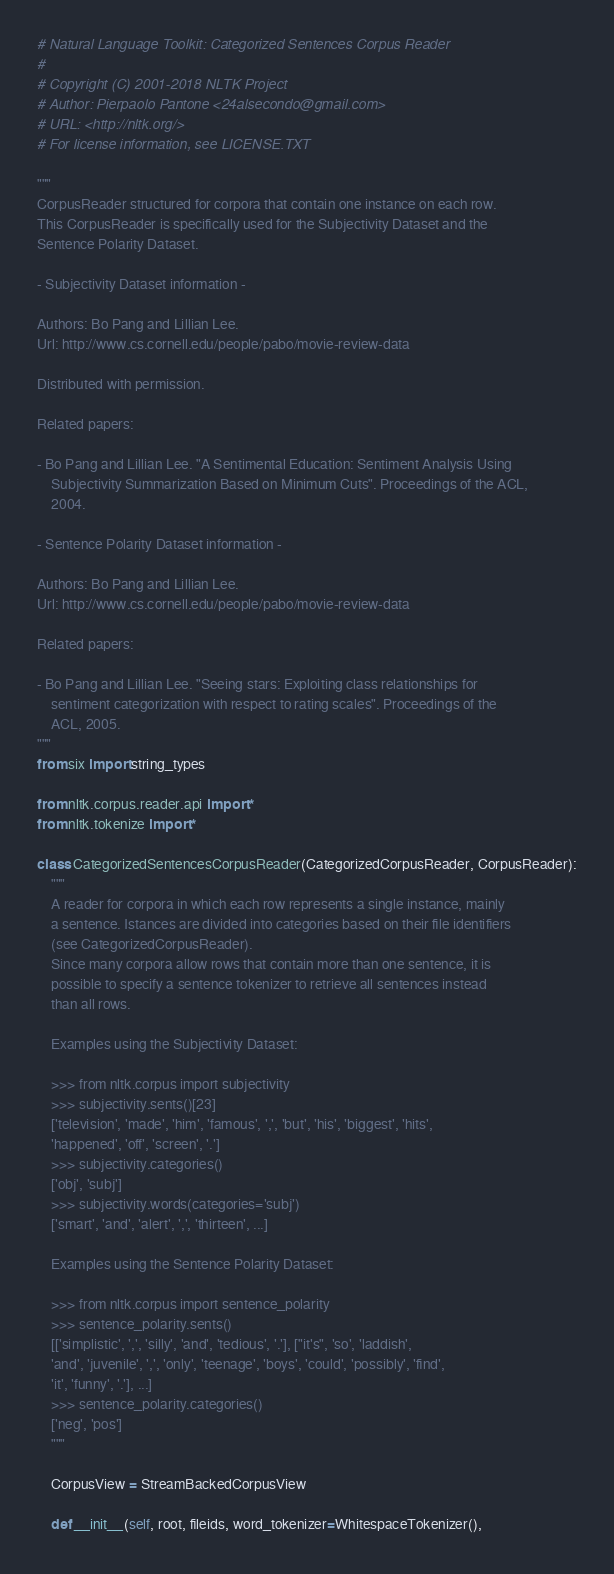<code> <loc_0><loc_0><loc_500><loc_500><_Python_># Natural Language Toolkit: Categorized Sentences Corpus Reader
#
# Copyright (C) 2001-2018 NLTK Project
# Author: Pierpaolo Pantone <24alsecondo@gmail.com>
# URL: <http://nltk.org/>
# For license information, see LICENSE.TXT

"""
CorpusReader structured for corpora that contain one instance on each row.
This CorpusReader is specifically used for the Subjectivity Dataset and the
Sentence Polarity Dataset.

- Subjectivity Dataset information -

Authors: Bo Pang and Lillian Lee.
Url: http://www.cs.cornell.edu/people/pabo/movie-review-data

Distributed with permission.

Related papers:

- Bo Pang and Lillian Lee. "A Sentimental Education: Sentiment Analysis Using
    Subjectivity Summarization Based on Minimum Cuts". Proceedings of the ACL,
    2004.

- Sentence Polarity Dataset information -

Authors: Bo Pang and Lillian Lee.
Url: http://www.cs.cornell.edu/people/pabo/movie-review-data

Related papers:

- Bo Pang and Lillian Lee. "Seeing stars: Exploiting class relationships for
    sentiment categorization with respect to rating scales". Proceedings of the
    ACL, 2005.
"""
from six import string_types

from nltk.corpus.reader.api import *
from nltk.tokenize import *

class CategorizedSentencesCorpusReader(CategorizedCorpusReader, CorpusReader):
    """
    A reader for corpora in which each row represents a single instance, mainly
    a sentence. Istances are divided into categories based on their file identifiers
    (see CategorizedCorpusReader).
    Since many corpora allow rows that contain more than one sentence, it is
    possible to specify a sentence tokenizer to retrieve all sentences instead
    than all rows.

    Examples using the Subjectivity Dataset:

    >>> from nltk.corpus import subjectivity
    >>> subjectivity.sents()[23]
    ['television', 'made', 'him', 'famous', ',', 'but', 'his', 'biggest', 'hits',
    'happened', 'off', 'screen', '.']
    >>> subjectivity.categories()
    ['obj', 'subj']
    >>> subjectivity.words(categories='subj')
    ['smart', 'and', 'alert', ',', 'thirteen', ...]

    Examples using the Sentence Polarity Dataset:

    >>> from nltk.corpus import sentence_polarity
    >>> sentence_polarity.sents()
    [['simplistic', ',', 'silly', 'and', 'tedious', '.'], ["it's", 'so', 'laddish',
    'and', 'juvenile', ',', 'only', 'teenage', 'boys', 'could', 'possibly', 'find',
    'it', 'funny', '.'], ...]
    >>> sentence_polarity.categories()
    ['neg', 'pos']
    """

    CorpusView = StreamBackedCorpusView

    def __init__(self, root, fileids, word_tokenizer=WhitespaceTokenizer(),</code> 